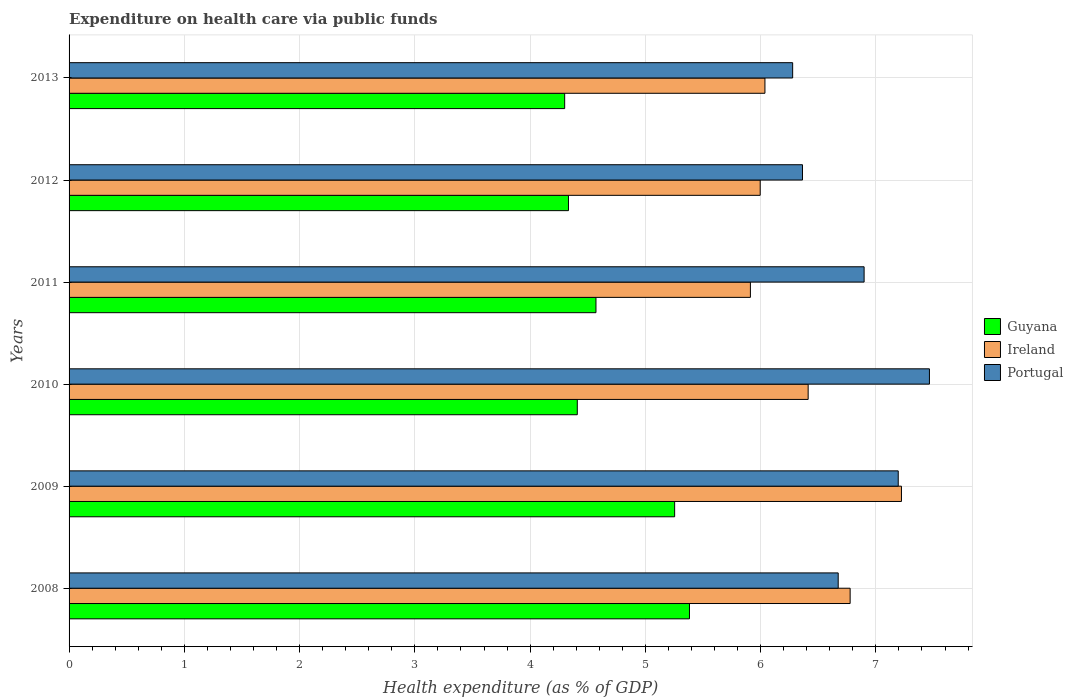How many different coloured bars are there?
Your answer should be compact. 3. How many groups of bars are there?
Provide a succinct answer. 6. Are the number of bars per tick equal to the number of legend labels?
Offer a very short reply. Yes. Are the number of bars on each tick of the Y-axis equal?
Your answer should be compact. Yes. How many bars are there on the 6th tick from the top?
Give a very brief answer. 3. How many bars are there on the 5th tick from the bottom?
Provide a short and direct response. 3. What is the expenditure made on health care in Portugal in 2008?
Keep it short and to the point. 6.67. Across all years, what is the maximum expenditure made on health care in Guyana?
Your answer should be compact. 5.38. Across all years, what is the minimum expenditure made on health care in Ireland?
Provide a short and direct response. 5.91. In which year was the expenditure made on health care in Ireland maximum?
Offer a very short reply. 2009. In which year was the expenditure made on health care in Guyana minimum?
Give a very brief answer. 2013. What is the total expenditure made on health care in Guyana in the graph?
Offer a terse response. 28.25. What is the difference between the expenditure made on health care in Ireland in 2008 and that in 2013?
Your answer should be compact. 0.74. What is the difference between the expenditure made on health care in Guyana in 2008 and the expenditure made on health care in Portugal in 2013?
Make the answer very short. -0.9. What is the average expenditure made on health care in Guyana per year?
Your answer should be compact. 4.71. In the year 2009, what is the difference between the expenditure made on health care in Ireland and expenditure made on health care in Portugal?
Your response must be concise. 0.03. What is the ratio of the expenditure made on health care in Ireland in 2009 to that in 2012?
Your response must be concise. 1.2. Is the difference between the expenditure made on health care in Ireland in 2008 and 2013 greater than the difference between the expenditure made on health care in Portugal in 2008 and 2013?
Keep it short and to the point. Yes. What is the difference between the highest and the second highest expenditure made on health care in Portugal?
Give a very brief answer. 0.27. What is the difference between the highest and the lowest expenditure made on health care in Guyana?
Provide a succinct answer. 1.08. In how many years, is the expenditure made on health care in Guyana greater than the average expenditure made on health care in Guyana taken over all years?
Keep it short and to the point. 2. What does the 3rd bar from the top in 2011 represents?
Make the answer very short. Guyana. What does the 3rd bar from the bottom in 2013 represents?
Your answer should be compact. Portugal. Are all the bars in the graph horizontal?
Your answer should be compact. Yes. What is the difference between two consecutive major ticks on the X-axis?
Offer a very short reply. 1. Are the values on the major ticks of X-axis written in scientific E-notation?
Ensure brevity in your answer.  No. Does the graph contain any zero values?
Your response must be concise. No. Does the graph contain grids?
Ensure brevity in your answer.  Yes. Where does the legend appear in the graph?
Offer a terse response. Center right. What is the title of the graph?
Make the answer very short. Expenditure on health care via public funds. Does "Turks and Caicos Islands" appear as one of the legend labels in the graph?
Keep it short and to the point. No. What is the label or title of the X-axis?
Provide a short and direct response. Health expenditure (as % of GDP). What is the Health expenditure (as % of GDP) in Guyana in 2008?
Your answer should be very brief. 5.38. What is the Health expenditure (as % of GDP) in Ireland in 2008?
Provide a succinct answer. 6.78. What is the Health expenditure (as % of GDP) in Portugal in 2008?
Give a very brief answer. 6.67. What is the Health expenditure (as % of GDP) in Guyana in 2009?
Make the answer very short. 5.25. What is the Health expenditure (as % of GDP) of Ireland in 2009?
Your answer should be compact. 7.22. What is the Health expenditure (as % of GDP) of Portugal in 2009?
Make the answer very short. 7.19. What is the Health expenditure (as % of GDP) in Guyana in 2010?
Provide a succinct answer. 4.41. What is the Health expenditure (as % of GDP) of Ireland in 2010?
Your answer should be very brief. 6.41. What is the Health expenditure (as % of GDP) of Portugal in 2010?
Your response must be concise. 7.46. What is the Health expenditure (as % of GDP) in Guyana in 2011?
Your answer should be compact. 4.57. What is the Health expenditure (as % of GDP) in Ireland in 2011?
Your answer should be compact. 5.91. What is the Health expenditure (as % of GDP) of Portugal in 2011?
Give a very brief answer. 6.9. What is the Health expenditure (as % of GDP) in Guyana in 2012?
Provide a succinct answer. 4.33. What is the Health expenditure (as % of GDP) of Ireland in 2012?
Offer a terse response. 6. What is the Health expenditure (as % of GDP) in Portugal in 2012?
Keep it short and to the point. 6.36. What is the Health expenditure (as % of GDP) of Guyana in 2013?
Offer a very short reply. 4.3. What is the Health expenditure (as % of GDP) of Ireland in 2013?
Your answer should be compact. 6.04. What is the Health expenditure (as % of GDP) of Portugal in 2013?
Offer a very short reply. 6.28. Across all years, what is the maximum Health expenditure (as % of GDP) of Guyana?
Give a very brief answer. 5.38. Across all years, what is the maximum Health expenditure (as % of GDP) in Ireland?
Make the answer very short. 7.22. Across all years, what is the maximum Health expenditure (as % of GDP) of Portugal?
Keep it short and to the point. 7.46. Across all years, what is the minimum Health expenditure (as % of GDP) of Guyana?
Your answer should be compact. 4.3. Across all years, what is the minimum Health expenditure (as % of GDP) in Ireland?
Offer a terse response. 5.91. Across all years, what is the minimum Health expenditure (as % of GDP) in Portugal?
Offer a very short reply. 6.28. What is the total Health expenditure (as % of GDP) of Guyana in the graph?
Provide a short and direct response. 28.25. What is the total Health expenditure (as % of GDP) in Ireland in the graph?
Offer a very short reply. 38.36. What is the total Health expenditure (as % of GDP) in Portugal in the graph?
Provide a short and direct response. 40.87. What is the difference between the Health expenditure (as % of GDP) in Guyana in 2008 and that in 2009?
Offer a terse response. 0.13. What is the difference between the Health expenditure (as % of GDP) of Ireland in 2008 and that in 2009?
Ensure brevity in your answer.  -0.45. What is the difference between the Health expenditure (as % of GDP) in Portugal in 2008 and that in 2009?
Provide a succinct answer. -0.52. What is the difference between the Health expenditure (as % of GDP) in Guyana in 2008 and that in 2010?
Make the answer very short. 0.97. What is the difference between the Health expenditure (as % of GDP) in Ireland in 2008 and that in 2010?
Your response must be concise. 0.36. What is the difference between the Health expenditure (as % of GDP) in Portugal in 2008 and that in 2010?
Keep it short and to the point. -0.79. What is the difference between the Health expenditure (as % of GDP) in Guyana in 2008 and that in 2011?
Offer a terse response. 0.81. What is the difference between the Health expenditure (as % of GDP) of Ireland in 2008 and that in 2011?
Give a very brief answer. 0.87. What is the difference between the Health expenditure (as % of GDP) in Portugal in 2008 and that in 2011?
Your response must be concise. -0.22. What is the difference between the Health expenditure (as % of GDP) of Guyana in 2008 and that in 2012?
Provide a succinct answer. 1.05. What is the difference between the Health expenditure (as % of GDP) in Ireland in 2008 and that in 2012?
Your answer should be compact. 0.78. What is the difference between the Health expenditure (as % of GDP) in Portugal in 2008 and that in 2012?
Provide a short and direct response. 0.31. What is the difference between the Health expenditure (as % of GDP) of Guyana in 2008 and that in 2013?
Your response must be concise. 1.08. What is the difference between the Health expenditure (as % of GDP) of Ireland in 2008 and that in 2013?
Provide a succinct answer. 0.74. What is the difference between the Health expenditure (as % of GDP) of Portugal in 2008 and that in 2013?
Make the answer very short. 0.4. What is the difference between the Health expenditure (as % of GDP) of Guyana in 2009 and that in 2010?
Keep it short and to the point. 0.84. What is the difference between the Health expenditure (as % of GDP) of Ireland in 2009 and that in 2010?
Offer a very short reply. 0.81. What is the difference between the Health expenditure (as % of GDP) in Portugal in 2009 and that in 2010?
Ensure brevity in your answer.  -0.27. What is the difference between the Health expenditure (as % of GDP) of Guyana in 2009 and that in 2011?
Ensure brevity in your answer.  0.68. What is the difference between the Health expenditure (as % of GDP) of Ireland in 2009 and that in 2011?
Your response must be concise. 1.31. What is the difference between the Health expenditure (as % of GDP) in Portugal in 2009 and that in 2011?
Your answer should be very brief. 0.3. What is the difference between the Health expenditure (as % of GDP) of Guyana in 2009 and that in 2012?
Keep it short and to the point. 0.92. What is the difference between the Health expenditure (as % of GDP) of Ireland in 2009 and that in 2012?
Keep it short and to the point. 1.23. What is the difference between the Health expenditure (as % of GDP) of Portugal in 2009 and that in 2012?
Ensure brevity in your answer.  0.83. What is the difference between the Health expenditure (as % of GDP) in Guyana in 2009 and that in 2013?
Make the answer very short. 0.95. What is the difference between the Health expenditure (as % of GDP) of Ireland in 2009 and that in 2013?
Your response must be concise. 1.18. What is the difference between the Health expenditure (as % of GDP) in Portugal in 2009 and that in 2013?
Provide a short and direct response. 0.92. What is the difference between the Health expenditure (as % of GDP) of Guyana in 2010 and that in 2011?
Give a very brief answer. -0.16. What is the difference between the Health expenditure (as % of GDP) in Ireland in 2010 and that in 2011?
Ensure brevity in your answer.  0.5. What is the difference between the Health expenditure (as % of GDP) of Portugal in 2010 and that in 2011?
Offer a very short reply. 0.57. What is the difference between the Health expenditure (as % of GDP) of Guyana in 2010 and that in 2012?
Ensure brevity in your answer.  0.08. What is the difference between the Health expenditure (as % of GDP) in Ireland in 2010 and that in 2012?
Give a very brief answer. 0.42. What is the difference between the Health expenditure (as % of GDP) of Portugal in 2010 and that in 2012?
Ensure brevity in your answer.  1.1. What is the difference between the Health expenditure (as % of GDP) of Guyana in 2010 and that in 2013?
Keep it short and to the point. 0.11. What is the difference between the Health expenditure (as % of GDP) in Ireland in 2010 and that in 2013?
Ensure brevity in your answer.  0.37. What is the difference between the Health expenditure (as % of GDP) in Portugal in 2010 and that in 2013?
Provide a short and direct response. 1.19. What is the difference between the Health expenditure (as % of GDP) in Guyana in 2011 and that in 2012?
Provide a succinct answer. 0.24. What is the difference between the Health expenditure (as % of GDP) of Ireland in 2011 and that in 2012?
Provide a succinct answer. -0.09. What is the difference between the Health expenditure (as % of GDP) of Portugal in 2011 and that in 2012?
Keep it short and to the point. 0.53. What is the difference between the Health expenditure (as % of GDP) of Guyana in 2011 and that in 2013?
Ensure brevity in your answer.  0.27. What is the difference between the Health expenditure (as % of GDP) in Ireland in 2011 and that in 2013?
Give a very brief answer. -0.13. What is the difference between the Health expenditure (as % of GDP) in Portugal in 2011 and that in 2013?
Keep it short and to the point. 0.62. What is the difference between the Health expenditure (as % of GDP) in Guyana in 2012 and that in 2013?
Provide a succinct answer. 0.03. What is the difference between the Health expenditure (as % of GDP) of Ireland in 2012 and that in 2013?
Give a very brief answer. -0.04. What is the difference between the Health expenditure (as % of GDP) in Portugal in 2012 and that in 2013?
Provide a short and direct response. 0.09. What is the difference between the Health expenditure (as % of GDP) of Guyana in 2008 and the Health expenditure (as % of GDP) of Ireland in 2009?
Keep it short and to the point. -1.84. What is the difference between the Health expenditure (as % of GDP) in Guyana in 2008 and the Health expenditure (as % of GDP) in Portugal in 2009?
Give a very brief answer. -1.81. What is the difference between the Health expenditure (as % of GDP) in Ireland in 2008 and the Health expenditure (as % of GDP) in Portugal in 2009?
Make the answer very short. -0.42. What is the difference between the Health expenditure (as % of GDP) in Guyana in 2008 and the Health expenditure (as % of GDP) in Ireland in 2010?
Offer a terse response. -1.03. What is the difference between the Health expenditure (as % of GDP) in Guyana in 2008 and the Health expenditure (as % of GDP) in Portugal in 2010?
Your response must be concise. -2.08. What is the difference between the Health expenditure (as % of GDP) of Ireland in 2008 and the Health expenditure (as % of GDP) of Portugal in 2010?
Your answer should be very brief. -0.69. What is the difference between the Health expenditure (as % of GDP) in Guyana in 2008 and the Health expenditure (as % of GDP) in Ireland in 2011?
Make the answer very short. -0.53. What is the difference between the Health expenditure (as % of GDP) in Guyana in 2008 and the Health expenditure (as % of GDP) in Portugal in 2011?
Provide a succinct answer. -1.52. What is the difference between the Health expenditure (as % of GDP) in Ireland in 2008 and the Health expenditure (as % of GDP) in Portugal in 2011?
Offer a very short reply. -0.12. What is the difference between the Health expenditure (as % of GDP) of Guyana in 2008 and the Health expenditure (as % of GDP) of Ireland in 2012?
Give a very brief answer. -0.61. What is the difference between the Health expenditure (as % of GDP) of Guyana in 2008 and the Health expenditure (as % of GDP) of Portugal in 2012?
Ensure brevity in your answer.  -0.98. What is the difference between the Health expenditure (as % of GDP) in Ireland in 2008 and the Health expenditure (as % of GDP) in Portugal in 2012?
Make the answer very short. 0.41. What is the difference between the Health expenditure (as % of GDP) of Guyana in 2008 and the Health expenditure (as % of GDP) of Ireland in 2013?
Offer a very short reply. -0.65. What is the difference between the Health expenditure (as % of GDP) in Guyana in 2008 and the Health expenditure (as % of GDP) in Portugal in 2013?
Your answer should be very brief. -0.9. What is the difference between the Health expenditure (as % of GDP) in Ireland in 2008 and the Health expenditure (as % of GDP) in Portugal in 2013?
Make the answer very short. 0.5. What is the difference between the Health expenditure (as % of GDP) in Guyana in 2009 and the Health expenditure (as % of GDP) in Ireland in 2010?
Your answer should be compact. -1.16. What is the difference between the Health expenditure (as % of GDP) in Guyana in 2009 and the Health expenditure (as % of GDP) in Portugal in 2010?
Keep it short and to the point. -2.21. What is the difference between the Health expenditure (as % of GDP) in Ireland in 2009 and the Health expenditure (as % of GDP) in Portugal in 2010?
Offer a very short reply. -0.24. What is the difference between the Health expenditure (as % of GDP) of Guyana in 2009 and the Health expenditure (as % of GDP) of Ireland in 2011?
Your answer should be very brief. -0.66. What is the difference between the Health expenditure (as % of GDP) in Guyana in 2009 and the Health expenditure (as % of GDP) in Portugal in 2011?
Your answer should be compact. -1.64. What is the difference between the Health expenditure (as % of GDP) in Ireland in 2009 and the Health expenditure (as % of GDP) in Portugal in 2011?
Offer a very short reply. 0.32. What is the difference between the Health expenditure (as % of GDP) of Guyana in 2009 and the Health expenditure (as % of GDP) of Ireland in 2012?
Your response must be concise. -0.74. What is the difference between the Health expenditure (as % of GDP) of Guyana in 2009 and the Health expenditure (as % of GDP) of Portugal in 2012?
Offer a terse response. -1.11. What is the difference between the Health expenditure (as % of GDP) in Ireland in 2009 and the Health expenditure (as % of GDP) in Portugal in 2012?
Your answer should be very brief. 0.86. What is the difference between the Health expenditure (as % of GDP) of Guyana in 2009 and the Health expenditure (as % of GDP) of Ireland in 2013?
Ensure brevity in your answer.  -0.78. What is the difference between the Health expenditure (as % of GDP) in Guyana in 2009 and the Health expenditure (as % of GDP) in Portugal in 2013?
Your answer should be compact. -1.02. What is the difference between the Health expenditure (as % of GDP) in Ireland in 2009 and the Health expenditure (as % of GDP) in Portugal in 2013?
Your response must be concise. 0.94. What is the difference between the Health expenditure (as % of GDP) of Guyana in 2010 and the Health expenditure (as % of GDP) of Ireland in 2011?
Your answer should be very brief. -1.5. What is the difference between the Health expenditure (as % of GDP) of Guyana in 2010 and the Health expenditure (as % of GDP) of Portugal in 2011?
Offer a terse response. -2.49. What is the difference between the Health expenditure (as % of GDP) of Ireland in 2010 and the Health expenditure (as % of GDP) of Portugal in 2011?
Make the answer very short. -0.49. What is the difference between the Health expenditure (as % of GDP) in Guyana in 2010 and the Health expenditure (as % of GDP) in Ireland in 2012?
Provide a succinct answer. -1.59. What is the difference between the Health expenditure (as % of GDP) in Guyana in 2010 and the Health expenditure (as % of GDP) in Portugal in 2012?
Your response must be concise. -1.95. What is the difference between the Health expenditure (as % of GDP) in Ireland in 2010 and the Health expenditure (as % of GDP) in Portugal in 2012?
Keep it short and to the point. 0.05. What is the difference between the Health expenditure (as % of GDP) of Guyana in 2010 and the Health expenditure (as % of GDP) of Ireland in 2013?
Your response must be concise. -1.63. What is the difference between the Health expenditure (as % of GDP) in Guyana in 2010 and the Health expenditure (as % of GDP) in Portugal in 2013?
Keep it short and to the point. -1.87. What is the difference between the Health expenditure (as % of GDP) of Ireland in 2010 and the Health expenditure (as % of GDP) of Portugal in 2013?
Offer a very short reply. 0.13. What is the difference between the Health expenditure (as % of GDP) of Guyana in 2011 and the Health expenditure (as % of GDP) of Ireland in 2012?
Provide a succinct answer. -1.43. What is the difference between the Health expenditure (as % of GDP) in Guyana in 2011 and the Health expenditure (as % of GDP) in Portugal in 2012?
Offer a very short reply. -1.79. What is the difference between the Health expenditure (as % of GDP) of Ireland in 2011 and the Health expenditure (as % of GDP) of Portugal in 2012?
Your answer should be compact. -0.45. What is the difference between the Health expenditure (as % of GDP) in Guyana in 2011 and the Health expenditure (as % of GDP) in Ireland in 2013?
Keep it short and to the point. -1.47. What is the difference between the Health expenditure (as % of GDP) of Guyana in 2011 and the Health expenditure (as % of GDP) of Portugal in 2013?
Offer a terse response. -1.71. What is the difference between the Health expenditure (as % of GDP) in Ireland in 2011 and the Health expenditure (as % of GDP) in Portugal in 2013?
Your response must be concise. -0.37. What is the difference between the Health expenditure (as % of GDP) in Guyana in 2012 and the Health expenditure (as % of GDP) in Ireland in 2013?
Your answer should be compact. -1.7. What is the difference between the Health expenditure (as % of GDP) of Guyana in 2012 and the Health expenditure (as % of GDP) of Portugal in 2013?
Keep it short and to the point. -1.95. What is the difference between the Health expenditure (as % of GDP) in Ireland in 2012 and the Health expenditure (as % of GDP) in Portugal in 2013?
Provide a succinct answer. -0.28. What is the average Health expenditure (as % of GDP) in Guyana per year?
Ensure brevity in your answer.  4.71. What is the average Health expenditure (as % of GDP) in Ireland per year?
Provide a succinct answer. 6.39. What is the average Health expenditure (as % of GDP) in Portugal per year?
Your answer should be compact. 6.81. In the year 2008, what is the difference between the Health expenditure (as % of GDP) of Guyana and Health expenditure (as % of GDP) of Ireland?
Offer a terse response. -1.39. In the year 2008, what is the difference between the Health expenditure (as % of GDP) of Guyana and Health expenditure (as % of GDP) of Portugal?
Your response must be concise. -1.29. In the year 2008, what is the difference between the Health expenditure (as % of GDP) in Ireland and Health expenditure (as % of GDP) in Portugal?
Make the answer very short. 0.1. In the year 2009, what is the difference between the Health expenditure (as % of GDP) of Guyana and Health expenditure (as % of GDP) of Ireland?
Keep it short and to the point. -1.97. In the year 2009, what is the difference between the Health expenditure (as % of GDP) of Guyana and Health expenditure (as % of GDP) of Portugal?
Give a very brief answer. -1.94. In the year 2009, what is the difference between the Health expenditure (as % of GDP) in Ireland and Health expenditure (as % of GDP) in Portugal?
Keep it short and to the point. 0.03. In the year 2010, what is the difference between the Health expenditure (as % of GDP) of Guyana and Health expenditure (as % of GDP) of Ireland?
Your answer should be very brief. -2. In the year 2010, what is the difference between the Health expenditure (as % of GDP) of Guyana and Health expenditure (as % of GDP) of Portugal?
Your response must be concise. -3.06. In the year 2010, what is the difference between the Health expenditure (as % of GDP) of Ireland and Health expenditure (as % of GDP) of Portugal?
Provide a succinct answer. -1.05. In the year 2011, what is the difference between the Health expenditure (as % of GDP) in Guyana and Health expenditure (as % of GDP) in Ireland?
Offer a terse response. -1.34. In the year 2011, what is the difference between the Health expenditure (as % of GDP) of Guyana and Health expenditure (as % of GDP) of Portugal?
Provide a succinct answer. -2.33. In the year 2011, what is the difference between the Health expenditure (as % of GDP) in Ireland and Health expenditure (as % of GDP) in Portugal?
Your response must be concise. -0.99. In the year 2012, what is the difference between the Health expenditure (as % of GDP) in Guyana and Health expenditure (as % of GDP) in Ireland?
Your response must be concise. -1.66. In the year 2012, what is the difference between the Health expenditure (as % of GDP) in Guyana and Health expenditure (as % of GDP) in Portugal?
Make the answer very short. -2.03. In the year 2012, what is the difference between the Health expenditure (as % of GDP) in Ireland and Health expenditure (as % of GDP) in Portugal?
Your answer should be compact. -0.37. In the year 2013, what is the difference between the Health expenditure (as % of GDP) in Guyana and Health expenditure (as % of GDP) in Ireland?
Keep it short and to the point. -1.74. In the year 2013, what is the difference between the Health expenditure (as % of GDP) in Guyana and Health expenditure (as % of GDP) in Portugal?
Offer a terse response. -1.98. In the year 2013, what is the difference between the Health expenditure (as % of GDP) of Ireland and Health expenditure (as % of GDP) of Portugal?
Keep it short and to the point. -0.24. What is the ratio of the Health expenditure (as % of GDP) of Guyana in 2008 to that in 2009?
Your answer should be compact. 1.02. What is the ratio of the Health expenditure (as % of GDP) of Ireland in 2008 to that in 2009?
Offer a terse response. 0.94. What is the ratio of the Health expenditure (as % of GDP) in Portugal in 2008 to that in 2009?
Provide a succinct answer. 0.93. What is the ratio of the Health expenditure (as % of GDP) of Guyana in 2008 to that in 2010?
Your answer should be very brief. 1.22. What is the ratio of the Health expenditure (as % of GDP) of Ireland in 2008 to that in 2010?
Give a very brief answer. 1.06. What is the ratio of the Health expenditure (as % of GDP) of Portugal in 2008 to that in 2010?
Your response must be concise. 0.89. What is the ratio of the Health expenditure (as % of GDP) of Guyana in 2008 to that in 2011?
Give a very brief answer. 1.18. What is the ratio of the Health expenditure (as % of GDP) of Ireland in 2008 to that in 2011?
Your answer should be compact. 1.15. What is the ratio of the Health expenditure (as % of GDP) in Portugal in 2008 to that in 2011?
Make the answer very short. 0.97. What is the ratio of the Health expenditure (as % of GDP) in Guyana in 2008 to that in 2012?
Make the answer very short. 1.24. What is the ratio of the Health expenditure (as % of GDP) in Ireland in 2008 to that in 2012?
Your answer should be compact. 1.13. What is the ratio of the Health expenditure (as % of GDP) of Portugal in 2008 to that in 2012?
Provide a succinct answer. 1.05. What is the ratio of the Health expenditure (as % of GDP) of Guyana in 2008 to that in 2013?
Make the answer very short. 1.25. What is the ratio of the Health expenditure (as % of GDP) in Ireland in 2008 to that in 2013?
Make the answer very short. 1.12. What is the ratio of the Health expenditure (as % of GDP) of Portugal in 2008 to that in 2013?
Provide a succinct answer. 1.06. What is the ratio of the Health expenditure (as % of GDP) in Guyana in 2009 to that in 2010?
Give a very brief answer. 1.19. What is the ratio of the Health expenditure (as % of GDP) in Ireland in 2009 to that in 2010?
Make the answer very short. 1.13. What is the ratio of the Health expenditure (as % of GDP) of Portugal in 2009 to that in 2010?
Your answer should be compact. 0.96. What is the ratio of the Health expenditure (as % of GDP) in Guyana in 2009 to that in 2011?
Your response must be concise. 1.15. What is the ratio of the Health expenditure (as % of GDP) of Ireland in 2009 to that in 2011?
Your answer should be very brief. 1.22. What is the ratio of the Health expenditure (as % of GDP) in Portugal in 2009 to that in 2011?
Your answer should be very brief. 1.04. What is the ratio of the Health expenditure (as % of GDP) in Guyana in 2009 to that in 2012?
Provide a succinct answer. 1.21. What is the ratio of the Health expenditure (as % of GDP) in Ireland in 2009 to that in 2012?
Your response must be concise. 1.2. What is the ratio of the Health expenditure (as % of GDP) in Portugal in 2009 to that in 2012?
Your answer should be very brief. 1.13. What is the ratio of the Health expenditure (as % of GDP) of Guyana in 2009 to that in 2013?
Keep it short and to the point. 1.22. What is the ratio of the Health expenditure (as % of GDP) of Ireland in 2009 to that in 2013?
Your response must be concise. 1.2. What is the ratio of the Health expenditure (as % of GDP) in Portugal in 2009 to that in 2013?
Give a very brief answer. 1.15. What is the ratio of the Health expenditure (as % of GDP) of Guyana in 2010 to that in 2011?
Make the answer very short. 0.96. What is the ratio of the Health expenditure (as % of GDP) of Ireland in 2010 to that in 2011?
Offer a very short reply. 1.08. What is the ratio of the Health expenditure (as % of GDP) of Portugal in 2010 to that in 2011?
Make the answer very short. 1.08. What is the ratio of the Health expenditure (as % of GDP) of Guyana in 2010 to that in 2012?
Make the answer very short. 1.02. What is the ratio of the Health expenditure (as % of GDP) of Ireland in 2010 to that in 2012?
Make the answer very short. 1.07. What is the ratio of the Health expenditure (as % of GDP) of Portugal in 2010 to that in 2012?
Ensure brevity in your answer.  1.17. What is the ratio of the Health expenditure (as % of GDP) in Guyana in 2010 to that in 2013?
Offer a very short reply. 1.03. What is the ratio of the Health expenditure (as % of GDP) of Ireland in 2010 to that in 2013?
Provide a short and direct response. 1.06. What is the ratio of the Health expenditure (as % of GDP) of Portugal in 2010 to that in 2013?
Your answer should be very brief. 1.19. What is the ratio of the Health expenditure (as % of GDP) of Guyana in 2011 to that in 2012?
Ensure brevity in your answer.  1.06. What is the ratio of the Health expenditure (as % of GDP) of Ireland in 2011 to that in 2012?
Your answer should be compact. 0.99. What is the ratio of the Health expenditure (as % of GDP) in Portugal in 2011 to that in 2012?
Give a very brief answer. 1.08. What is the ratio of the Health expenditure (as % of GDP) in Guyana in 2011 to that in 2013?
Provide a short and direct response. 1.06. What is the ratio of the Health expenditure (as % of GDP) of Ireland in 2011 to that in 2013?
Offer a terse response. 0.98. What is the ratio of the Health expenditure (as % of GDP) of Portugal in 2011 to that in 2013?
Give a very brief answer. 1.1. What is the ratio of the Health expenditure (as % of GDP) in Guyana in 2012 to that in 2013?
Your answer should be compact. 1.01. What is the ratio of the Health expenditure (as % of GDP) in Portugal in 2012 to that in 2013?
Keep it short and to the point. 1.01. What is the difference between the highest and the second highest Health expenditure (as % of GDP) in Guyana?
Your response must be concise. 0.13. What is the difference between the highest and the second highest Health expenditure (as % of GDP) in Ireland?
Provide a succinct answer. 0.45. What is the difference between the highest and the second highest Health expenditure (as % of GDP) of Portugal?
Make the answer very short. 0.27. What is the difference between the highest and the lowest Health expenditure (as % of GDP) of Guyana?
Make the answer very short. 1.08. What is the difference between the highest and the lowest Health expenditure (as % of GDP) of Ireland?
Offer a terse response. 1.31. What is the difference between the highest and the lowest Health expenditure (as % of GDP) of Portugal?
Ensure brevity in your answer.  1.19. 